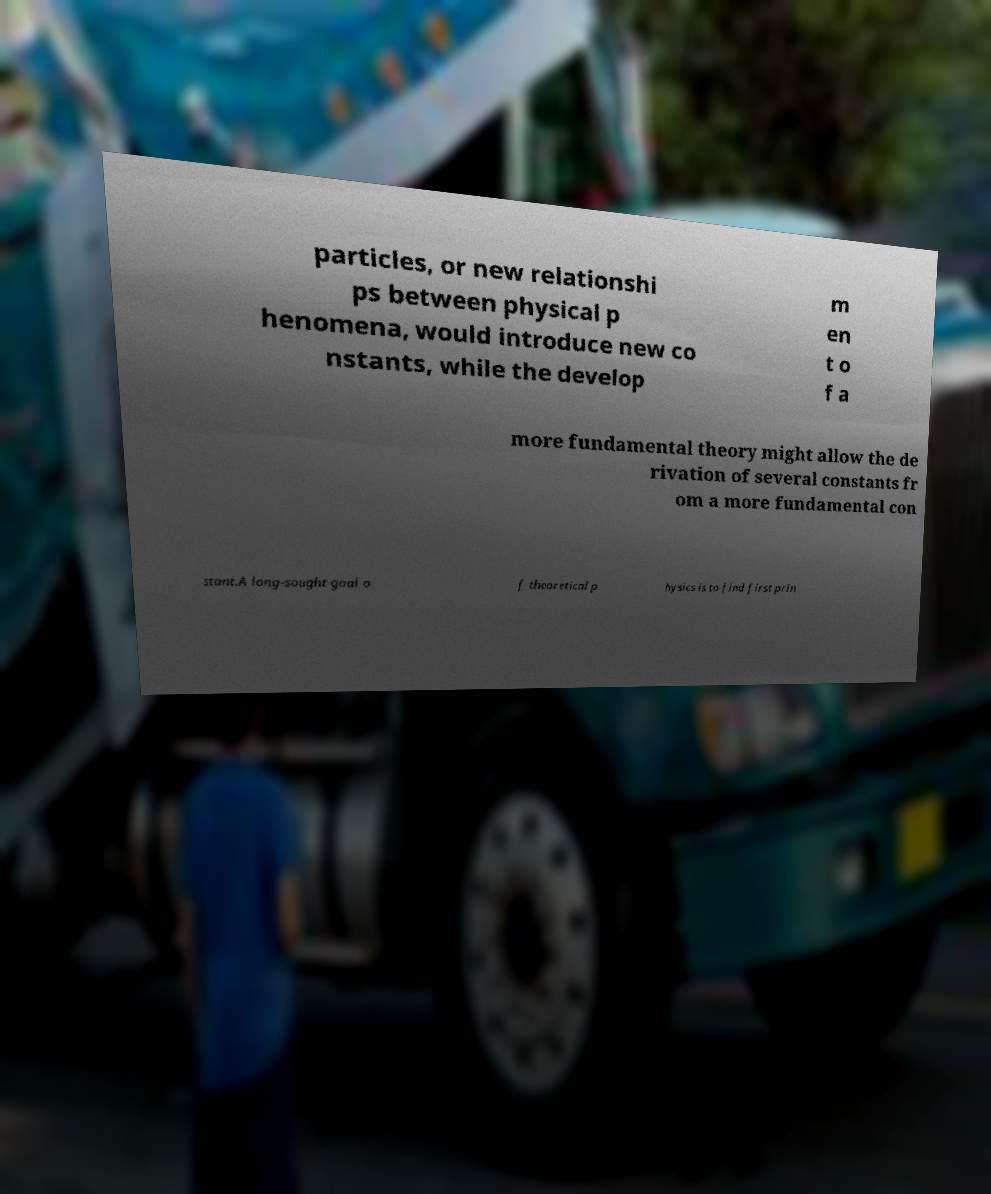There's text embedded in this image that I need extracted. Can you transcribe it verbatim? particles, or new relationshi ps between physical p henomena, would introduce new co nstants, while the develop m en t o f a more fundamental theory might allow the de rivation of several constants fr om a more fundamental con stant.A long-sought goal o f theoretical p hysics is to find first prin 